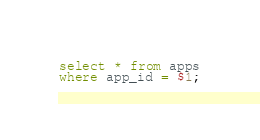Convert code to text. <code><loc_0><loc_0><loc_500><loc_500><_SQL_>select * from apps
where app_id = $1;</code> 